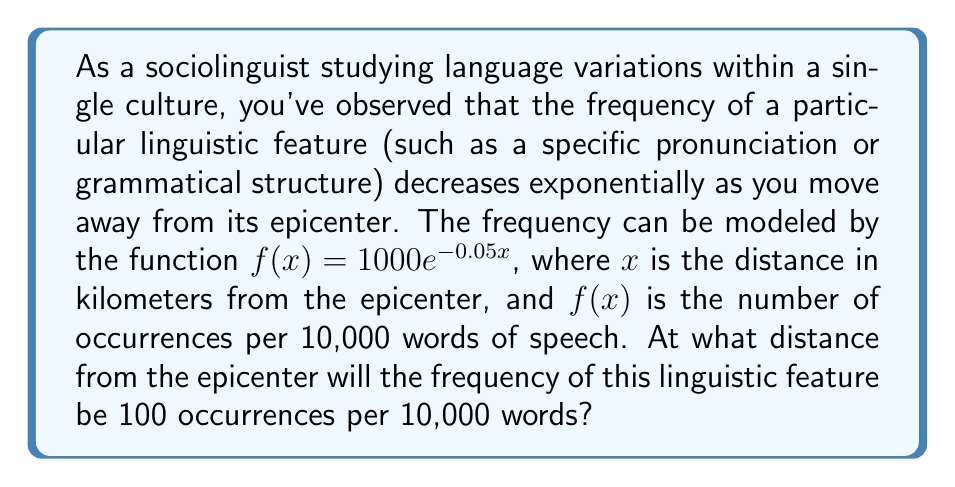What is the answer to this math problem? To solve this problem, we need to use the properties of exponential functions and logarithms. Let's approach this step-by-step:

1) We are given the exponential function: $f(x) = 1000e^{-0.05x}$

2) We want to find the value of $x$ when $f(x) = 100$. So, we can set up the equation:

   $100 = 1000e^{-0.05x}$

3) First, let's divide both sides by 1000:

   $\frac{100}{1000} = e^{-0.05x}$
   $0.1 = e^{-0.05x}$

4) Now, we can take the natural logarithm of both sides. Remember, $\ln(e^x) = x$:

   $\ln(0.1) = \ln(e^{-0.05x})$
   $\ln(0.1) = -0.05x$

5) Solve for $x$ by dividing both sides by -0.05:

   $\frac{\ln(0.1)}{-0.05} = x$

6) Calculate the value:
   $x = \frac{\ln(0.1)}{-0.05} \approx 46.05$

Therefore, the linguistic feature will have a frequency of 100 occurrences per 10,000 words at approximately 46.05 kilometers from the epicenter.
Answer: The frequency of the linguistic feature will be 100 occurrences per 10,000 words at approximately 46.05 kilometers from the epicenter. 